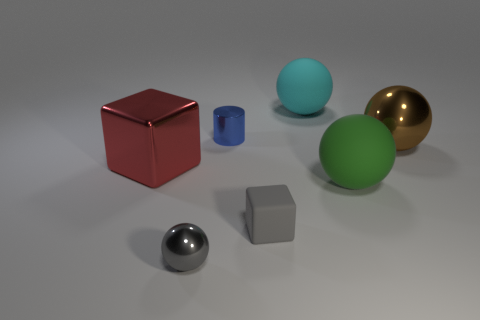How many other objects are the same color as the cylinder?
Your answer should be compact. 0. Are there fewer blue metallic cylinders than purple metallic spheres?
Your answer should be compact. No. What number of matte spheres are behind the red shiny block that is on the left side of the metallic sphere right of the large cyan rubber thing?
Make the answer very short. 1. What size is the matte ball that is behind the metallic cube?
Give a very brief answer. Large. Does the metallic object on the right side of the small matte object have the same shape as the tiny gray shiny thing?
Offer a very short reply. Yes. There is a brown object that is the same shape as the gray metallic object; what material is it?
Ensure brevity in your answer.  Metal. Is there any other thing that has the same size as the gray metal thing?
Offer a very short reply. Yes. Are there any rubber things?
Give a very brief answer. Yes. What is the material of the big thing to the left of the cylinder on the left side of the sphere that is behind the small blue cylinder?
Offer a very short reply. Metal. There is a small matte thing; does it have the same shape as the object on the left side of the gray shiny object?
Make the answer very short. Yes. 